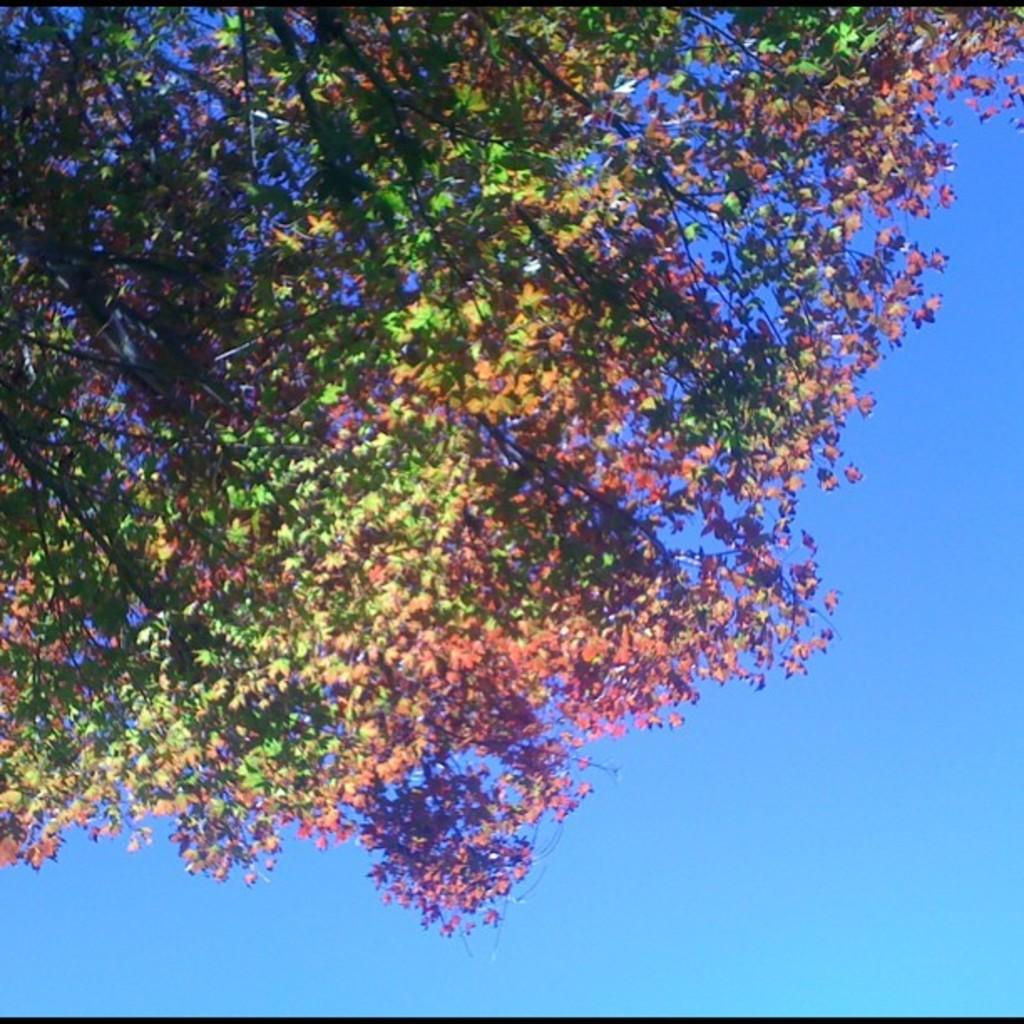What type of plant can be seen in the image? There is a tree in the image. What part of the natural environment is visible behind the tree? The sky is visible behind the tree in the image. What type of fruit is hanging from the tree in the image? There is no fruit hanging from the tree in the image. Can you provide a list of activities that are taking place in the image? There are no activities taking place in the image; it primarily features a tree and the sky. 